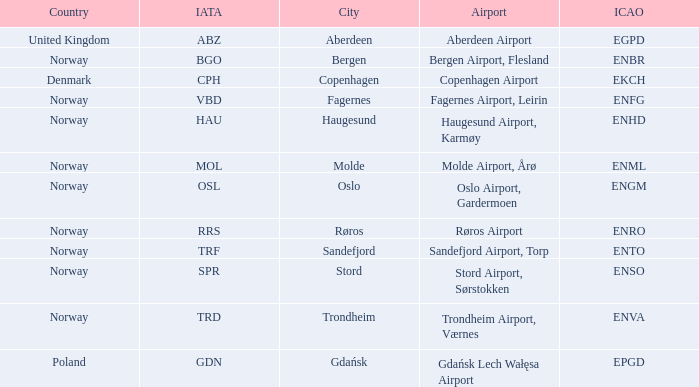What is City of Sandefjord in Norway's IATA? TRF. 